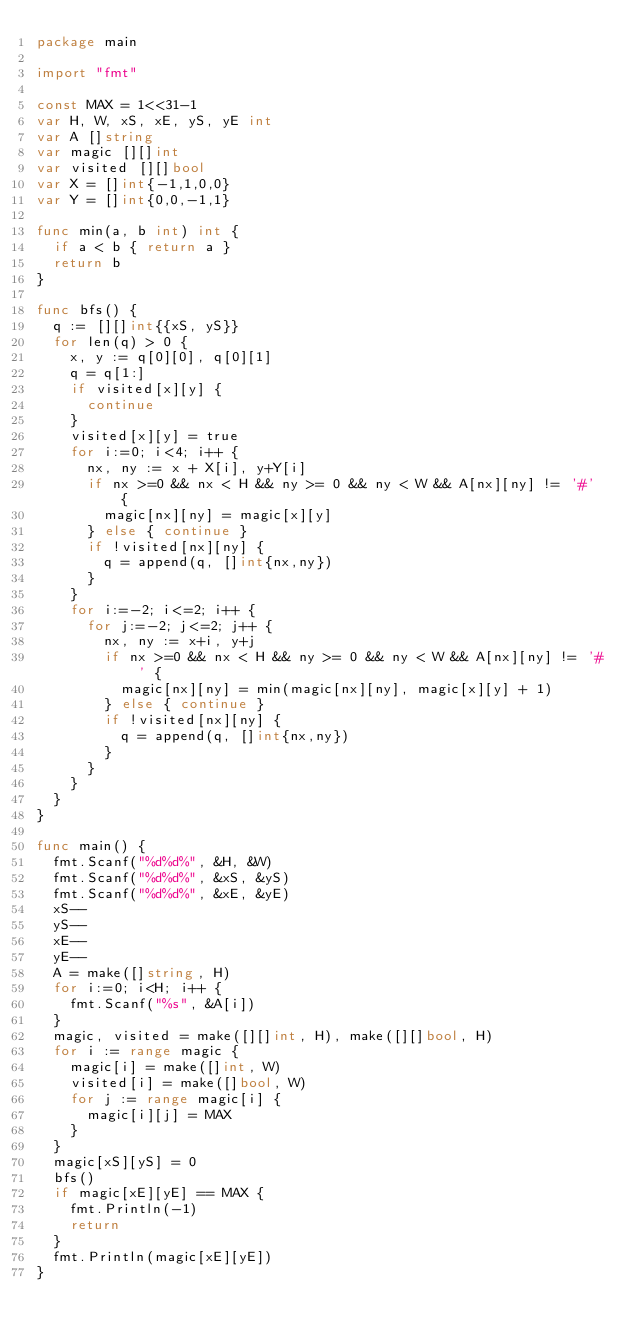<code> <loc_0><loc_0><loc_500><loc_500><_Go_>package main

import "fmt"

const MAX = 1<<31-1
var H, W, xS, xE, yS, yE int
var A []string
var magic [][]int
var visited [][]bool
var X = []int{-1,1,0,0}
var Y = []int{0,0,-1,1}

func min(a, b int) int {
	if a < b { return a }
	return b
}

func bfs() {
	q := [][]int{{xS, yS}}
	for len(q) > 0 {
		x, y := q[0][0], q[0][1]
		q = q[1:]
		if visited[x][y] {
			continue
		}
		visited[x][y] = true
		for i:=0; i<4; i++ {
			nx, ny := x + X[i], y+Y[i]
			if nx >=0 && nx < H && ny >= 0 && ny < W && A[nx][ny] != '#' {
				magic[nx][ny] = magic[x][y]
			} else { continue }
			if !visited[nx][ny] {
				q = append(q, []int{nx,ny})
			}
		}
		for i:=-2; i<=2; i++ {
			for j:=-2; j<=2; j++ {
				nx, ny := x+i, y+j
				if nx >=0 && nx < H && ny >= 0 && ny < W && A[nx][ny] != '#' {
					magic[nx][ny] = min(magic[nx][ny], magic[x][y] + 1)
				} else { continue }
				if !visited[nx][ny] {
					q = append(q, []int{nx,ny})
				}
			}
		}
	}
}

func main() {
	fmt.Scanf("%d%d%", &H, &W)
	fmt.Scanf("%d%d%", &xS, &yS)
	fmt.Scanf("%d%d%", &xE, &yE)
	xS--
	yS--
	xE--
	yE--
	A = make([]string, H)
	for i:=0; i<H; i++ {
		fmt.Scanf("%s", &A[i])
	}
	magic, visited = make([][]int, H), make([][]bool, H)
	for i := range magic {
		magic[i] = make([]int, W)
		visited[i] = make([]bool, W)
		for j := range magic[i] {
			magic[i][j] = MAX
		}
	}
	magic[xS][yS] = 0
	bfs()
	if magic[xE][yE] == MAX {
		fmt.Println(-1)
		return
	}
	fmt.Println(magic[xE][yE])
}
</code> 